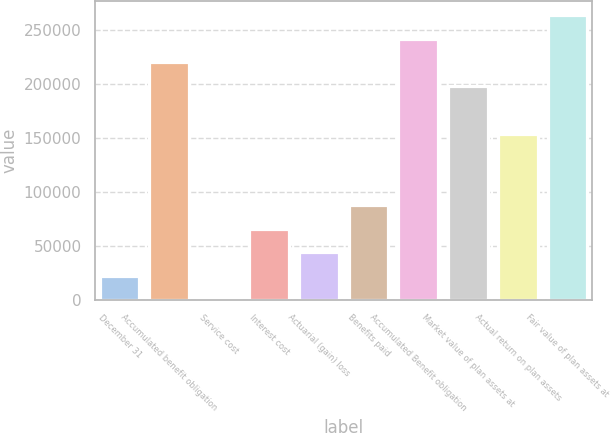Convert chart. <chart><loc_0><loc_0><loc_500><loc_500><bar_chart><fcel>December 31<fcel>Accumulated benefit obligation<fcel>Service cost<fcel>Interest cost<fcel>Actuarial (gain) loss<fcel>Benefits paid<fcel>Accumulated Benefit obligation<fcel>Market value of plan assets at<fcel>Actual return on plan assets<fcel>Fair value of plan assets at<nl><fcel>22042.7<fcel>219905<fcel>58<fcel>66012.1<fcel>44027.4<fcel>87996.8<fcel>241890<fcel>197920<fcel>153951<fcel>263874<nl></chart> 